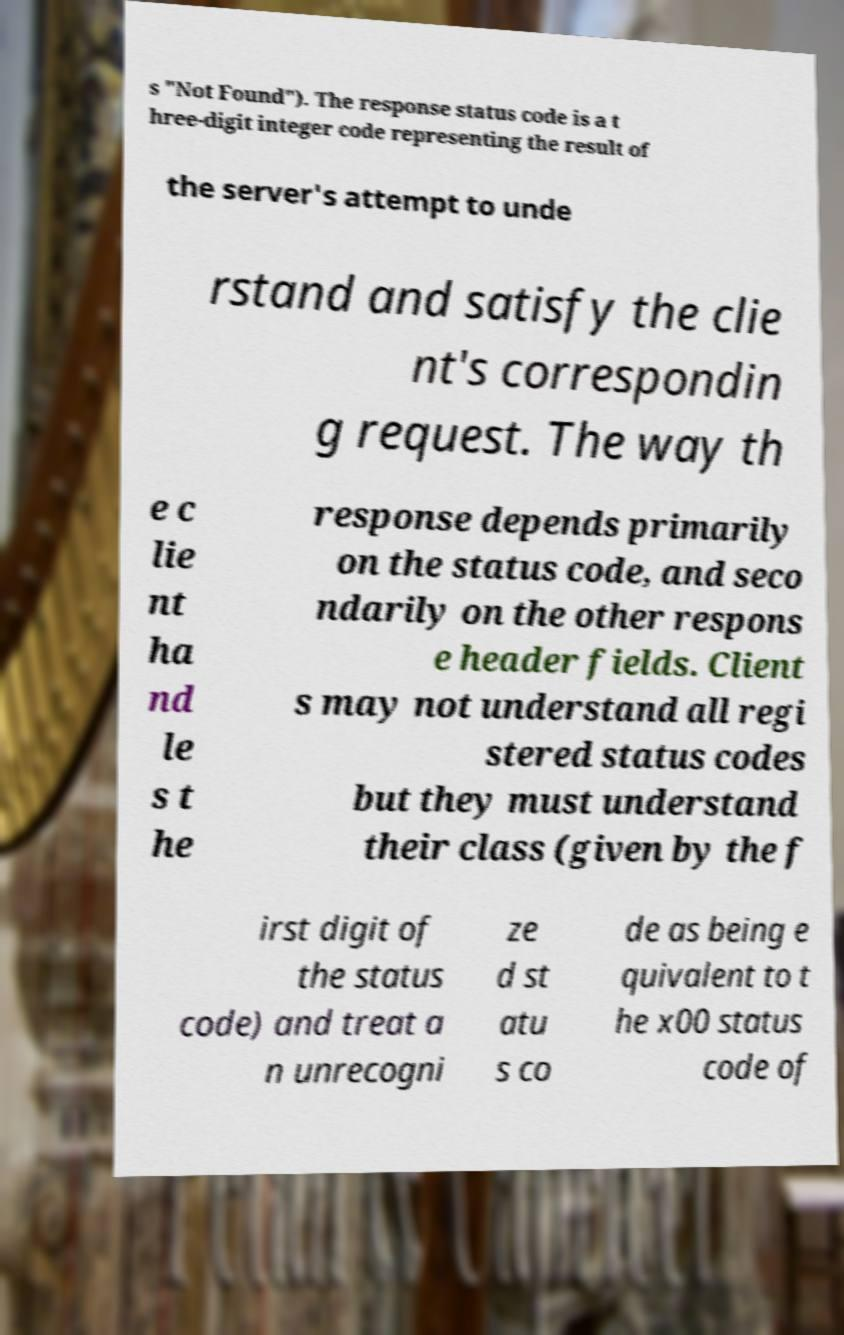There's text embedded in this image that I need extracted. Can you transcribe it verbatim? s "Not Found"). The response status code is a t hree-digit integer code representing the result of the server's attempt to unde rstand and satisfy the clie nt's correspondin g request. The way th e c lie nt ha nd le s t he response depends primarily on the status code, and seco ndarily on the other respons e header fields. Client s may not understand all regi stered status codes but they must understand their class (given by the f irst digit of the status code) and treat a n unrecogni ze d st atu s co de as being e quivalent to t he x00 status code of 